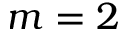<formula> <loc_0><loc_0><loc_500><loc_500>m = 2</formula> 